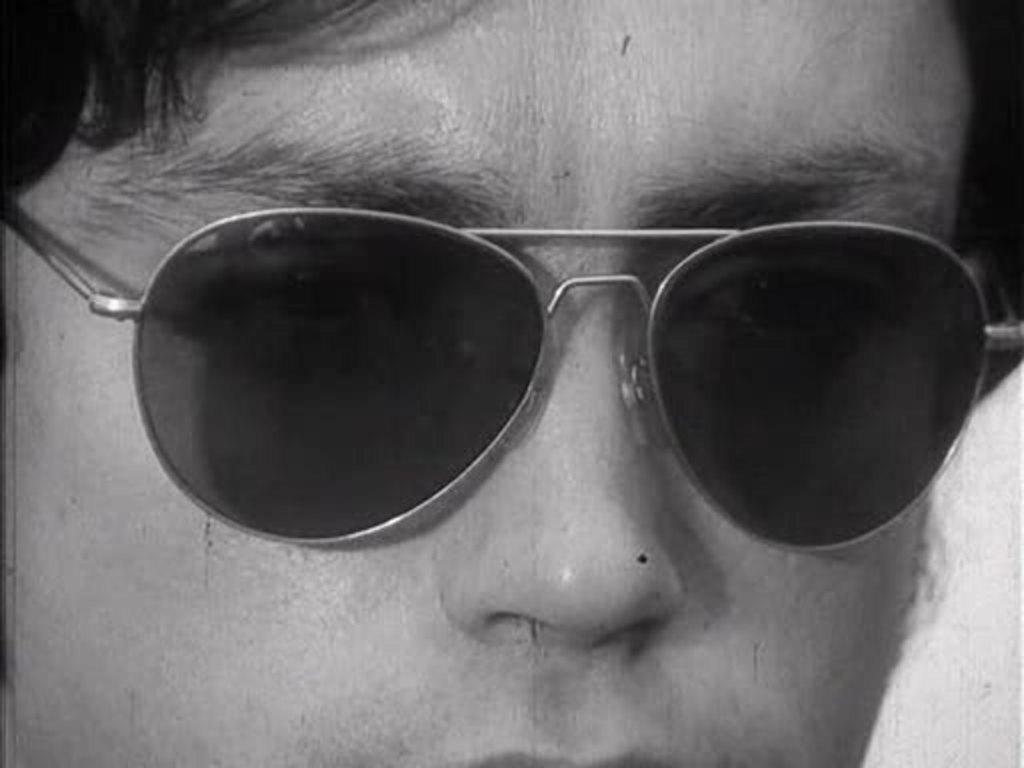Could you give a brief overview of what you see in this image? In this picture there is a close view of the boy wearing black sunglasses. 